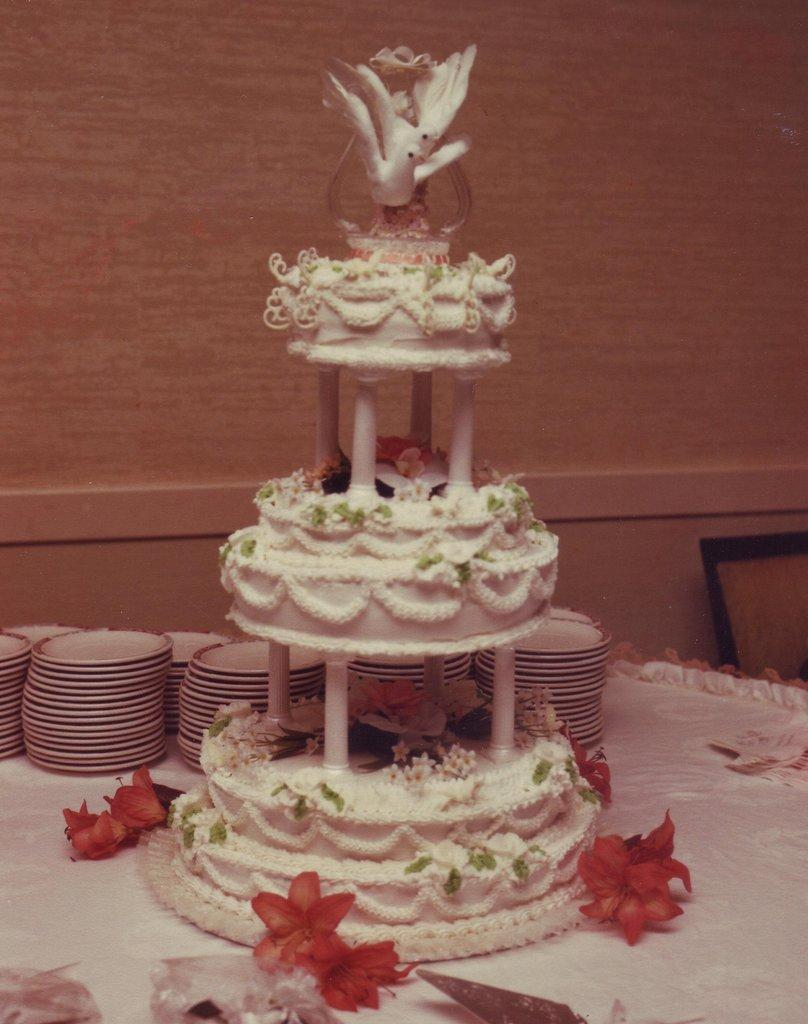What is the main subject on the table in the image? There is a cake on a table in the image. What else can be seen on the table besides the cake? There are plates visible in the image. What type of soda is being served with the cake in the image? There is no soda present in the image; only a cake and plates are visible. How many hours does it take to bake the cake in the image? The provided facts do not mention any information about the time it took to bake the cake, so it cannot be determined from the image. 